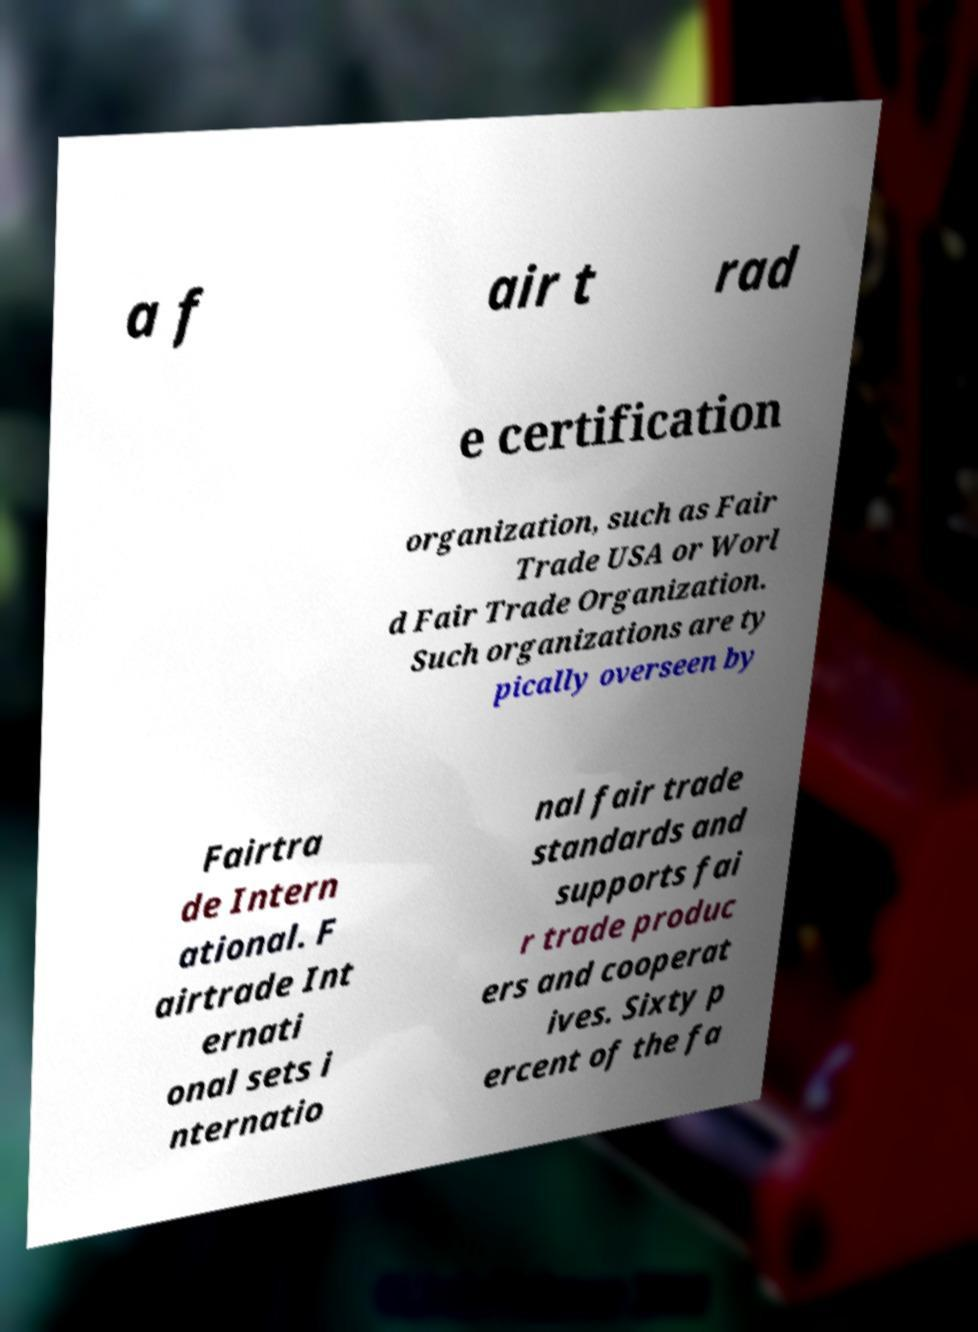Please identify and transcribe the text found in this image. a f air t rad e certification organization, such as Fair Trade USA or Worl d Fair Trade Organization. Such organizations are ty pically overseen by Fairtra de Intern ational. F airtrade Int ernati onal sets i nternatio nal fair trade standards and supports fai r trade produc ers and cooperat ives. Sixty p ercent of the fa 